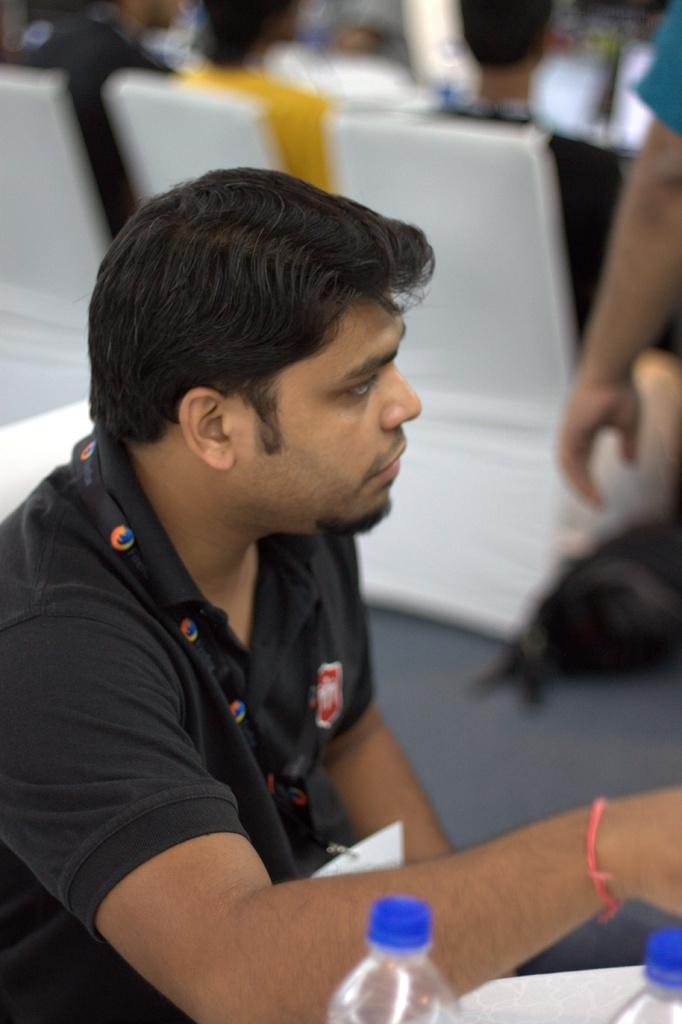Who is the main subject in the image? There is a man in the image. What is the man wearing? The man is wearing a black t-shirt. Does the man have any distinguishing features? Yes, the man has a tag. What can be seen in the background of the image? There are many people sitting on chairs in the background of the image. What type of substance is the man holding in the image? There is no substance visible in the man's hands in the image. Can you tell me how many snails are crawling on the man's shirt in the image? There are no snails present in the image. 